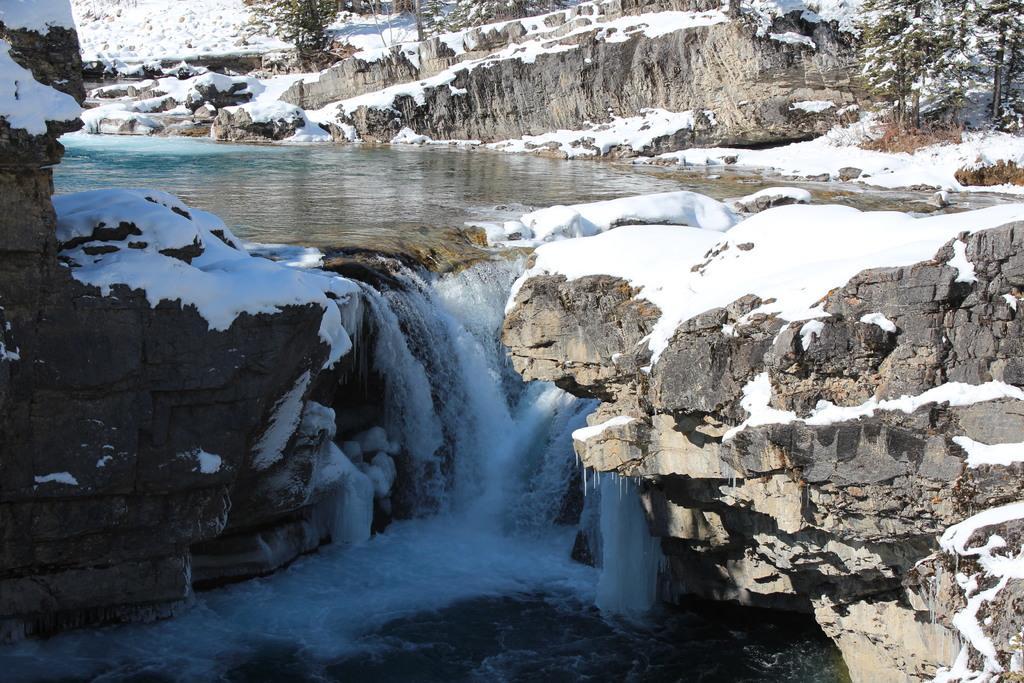How would you summarize this image in a sentence or two? We can see snow, water, rocks and trees. 